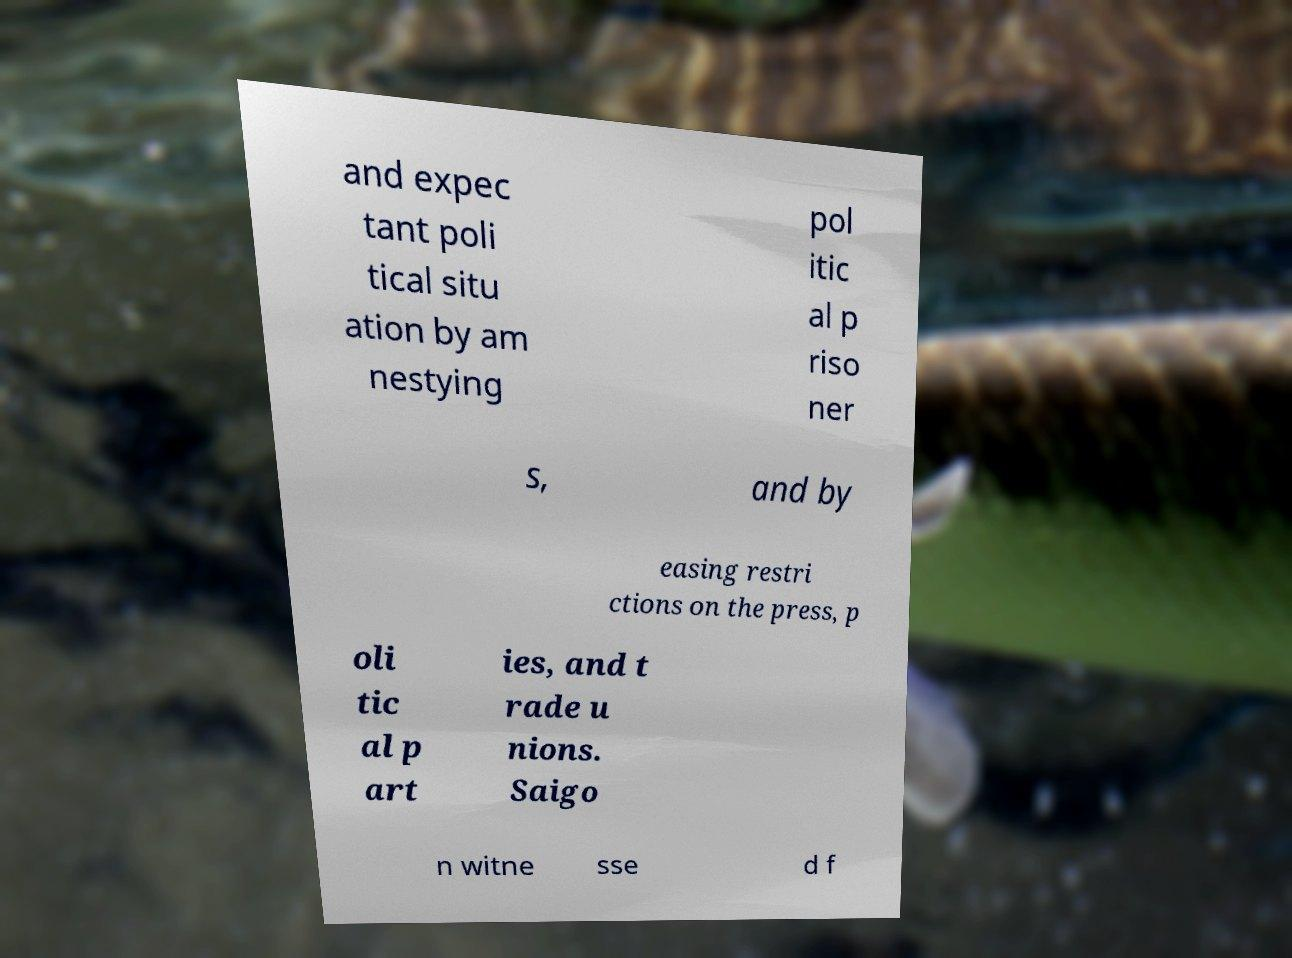What messages or text are displayed in this image? I need them in a readable, typed format. and expec tant poli tical situ ation by am nestying pol itic al p riso ner s, and by easing restri ctions on the press, p oli tic al p art ies, and t rade u nions. Saigo n witne sse d f 